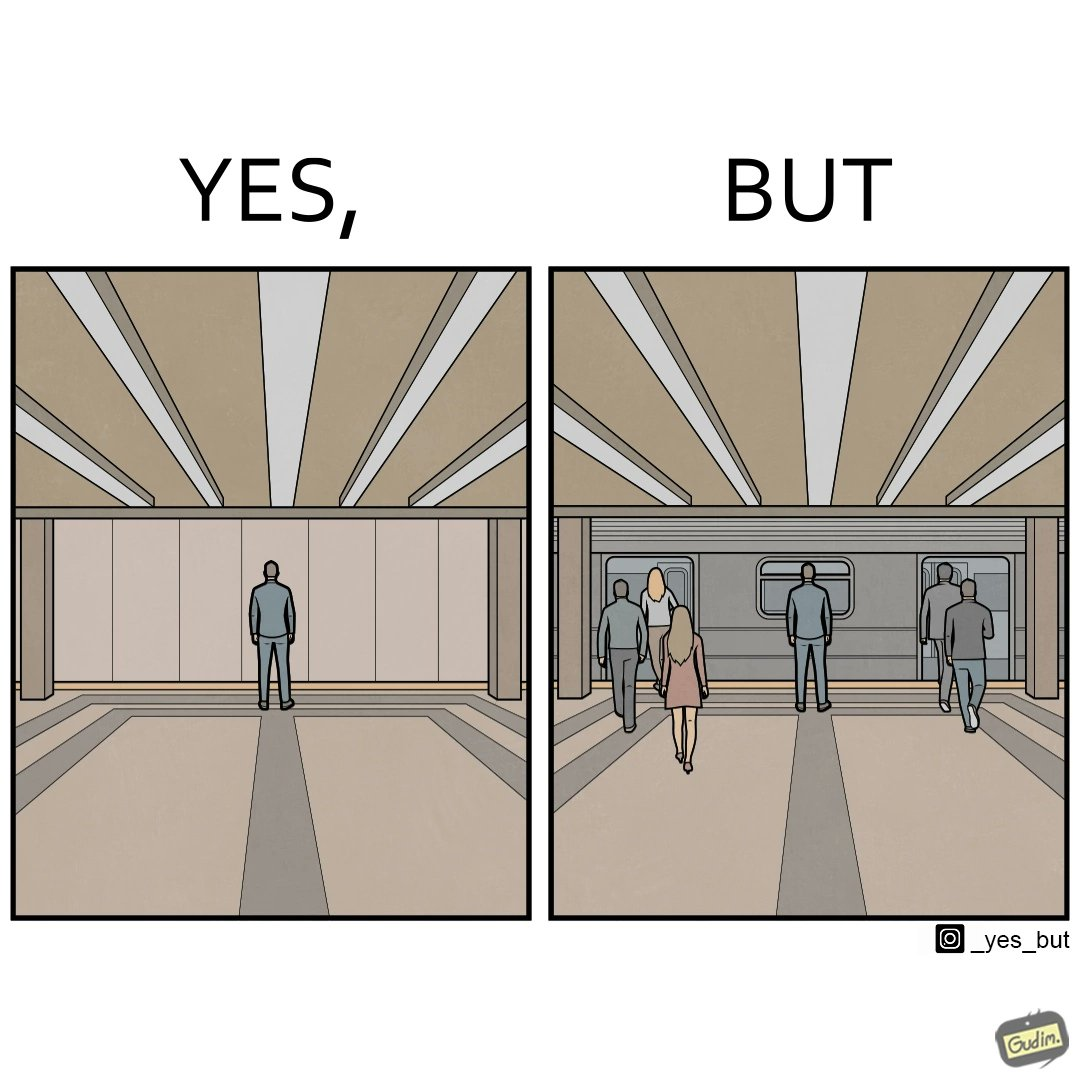Describe the content of this image. The image is of a metro or railway station which shows that the person in left is standing in the middle at the correct place to board the train, but in the right, the doors of the train are wronglyÃÂ positioned 